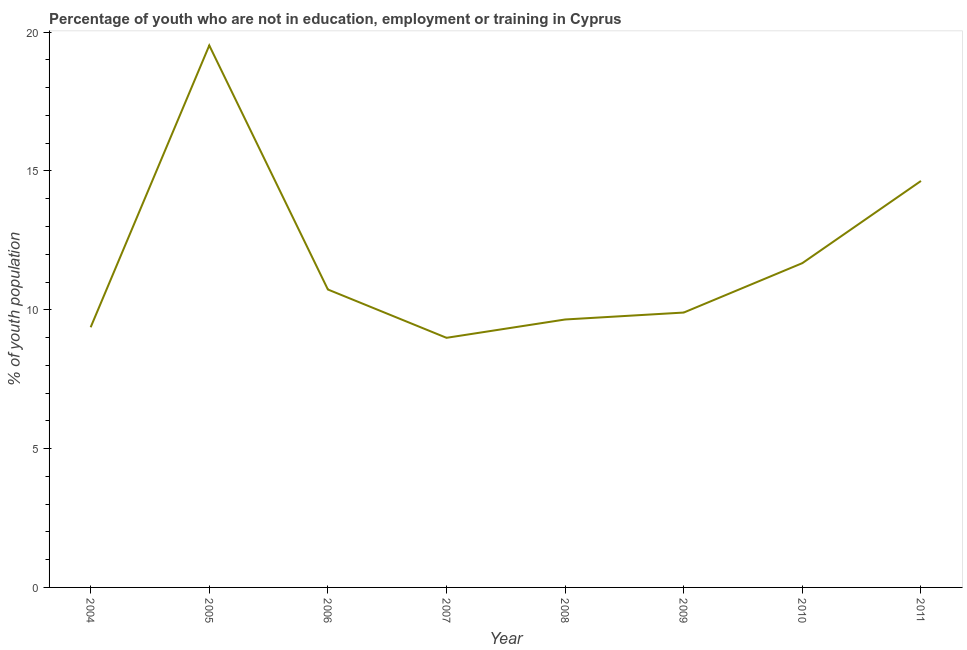What is the unemployed youth population in 2004?
Your response must be concise. 9.37. Across all years, what is the maximum unemployed youth population?
Offer a very short reply. 19.52. Across all years, what is the minimum unemployed youth population?
Ensure brevity in your answer.  8.99. What is the sum of the unemployed youth population?
Provide a short and direct response. 94.48. What is the difference between the unemployed youth population in 2009 and 2011?
Provide a short and direct response. -4.74. What is the average unemployed youth population per year?
Your answer should be very brief. 11.81. What is the median unemployed youth population?
Give a very brief answer. 10.31. Do a majority of the years between 2004 and 2005 (inclusive) have unemployed youth population greater than 13 %?
Offer a terse response. No. What is the ratio of the unemployed youth population in 2006 to that in 2010?
Keep it short and to the point. 0.92. Is the difference between the unemployed youth population in 2006 and 2010 greater than the difference between any two years?
Offer a terse response. No. What is the difference between the highest and the second highest unemployed youth population?
Make the answer very short. 4.88. What is the difference between the highest and the lowest unemployed youth population?
Provide a succinct answer. 10.53. In how many years, is the unemployed youth population greater than the average unemployed youth population taken over all years?
Your response must be concise. 2. Does the unemployed youth population monotonically increase over the years?
Give a very brief answer. No. How many lines are there?
Provide a succinct answer. 1. How many years are there in the graph?
Ensure brevity in your answer.  8. Does the graph contain grids?
Offer a terse response. No. What is the title of the graph?
Your answer should be very brief. Percentage of youth who are not in education, employment or training in Cyprus. What is the label or title of the Y-axis?
Offer a terse response. % of youth population. What is the % of youth population of 2004?
Offer a terse response. 9.37. What is the % of youth population in 2005?
Provide a succinct answer. 19.52. What is the % of youth population in 2006?
Your answer should be compact. 10.73. What is the % of youth population in 2007?
Keep it short and to the point. 8.99. What is the % of youth population of 2008?
Offer a very short reply. 9.65. What is the % of youth population of 2009?
Make the answer very short. 9.9. What is the % of youth population of 2010?
Ensure brevity in your answer.  11.68. What is the % of youth population in 2011?
Ensure brevity in your answer.  14.64. What is the difference between the % of youth population in 2004 and 2005?
Provide a succinct answer. -10.15. What is the difference between the % of youth population in 2004 and 2006?
Give a very brief answer. -1.36. What is the difference between the % of youth population in 2004 and 2007?
Offer a very short reply. 0.38. What is the difference between the % of youth population in 2004 and 2008?
Ensure brevity in your answer.  -0.28. What is the difference between the % of youth population in 2004 and 2009?
Ensure brevity in your answer.  -0.53. What is the difference between the % of youth population in 2004 and 2010?
Give a very brief answer. -2.31. What is the difference between the % of youth population in 2004 and 2011?
Your answer should be compact. -5.27. What is the difference between the % of youth population in 2005 and 2006?
Make the answer very short. 8.79. What is the difference between the % of youth population in 2005 and 2007?
Give a very brief answer. 10.53. What is the difference between the % of youth population in 2005 and 2008?
Your answer should be very brief. 9.87. What is the difference between the % of youth population in 2005 and 2009?
Your answer should be compact. 9.62. What is the difference between the % of youth population in 2005 and 2010?
Your response must be concise. 7.84. What is the difference between the % of youth population in 2005 and 2011?
Your answer should be compact. 4.88. What is the difference between the % of youth population in 2006 and 2007?
Give a very brief answer. 1.74. What is the difference between the % of youth population in 2006 and 2008?
Your answer should be compact. 1.08. What is the difference between the % of youth population in 2006 and 2009?
Make the answer very short. 0.83. What is the difference between the % of youth population in 2006 and 2010?
Your answer should be compact. -0.95. What is the difference between the % of youth population in 2006 and 2011?
Provide a short and direct response. -3.91. What is the difference between the % of youth population in 2007 and 2008?
Keep it short and to the point. -0.66. What is the difference between the % of youth population in 2007 and 2009?
Provide a short and direct response. -0.91. What is the difference between the % of youth population in 2007 and 2010?
Ensure brevity in your answer.  -2.69. What is the difference between the % of youth population in 2007 and 2011?
Offer a very short reply. -5.65. What is the difference between the % of youth population in 2008 and 2009?
Make the answer very short. -0.25. What is the difference between the % of youth population in 2008 and 2010?
Keep it short and to the point. -2.03. What is the difference between the % of youth population in 2008 and 2011?
Offer a very short reply. -4.99. What is the difference between the % of youth population in 2009 and 2010?
Your response must be concise. -1.78. What is the difference between the % of youth population in 2009 and 2011?
Offer a terse response. -4.74. What is the difference between the % of youth population in 2010 and 2011?
Ensure brevity in your answer.  -2.96. What is the ratio of the % of youth population in 2004 to that in 2005?
Keep it short and to the point. 0.48. What is the ratio of the % of youth population in 2004 to that in 2006?
Keep it short and to the point. 0.87. What is the ratio of the % of youth population in 2004 to that in 2007?
Keep it short and to the point. 1.04. What is the ratio of the % of youth population in 2004 to that in 2009?
Keep it short and to the point. 0.95. What is the ratio of the % of youth population in 2004 to that in 2010?
Give a very brief answer. 0.8. What is the ratio of the % of youth population in 2004 to that in 2011?
Your answer should be compact. 0.64. What is the ratio of the % of youth population in 2005 to that in 2006?
Ensure brevity in your answer.  1.82. What is the ratio of the % of youth population in 2005 to that in 2007?
Your response must be concise. 2.17. What is the ratio of the % of youth population in 2005 to that in 2008?
Your answer should be very brief. 2.02. What is the ratio of the % of youth population in 2005 to that in 2009?
Keep it short and to the point. 1.97. What is the ratio of the % of youth population in 2005 to that in 2010?
Make the answer very short. 1.67. What is the ratio of the % of youth population in 2005 to that in 2011?
Provide a short and direct response. 1.33. What is the ratio of the % of youth population in 2006 to that in 2007?
Your answer should be very brief. 1.19. What is the ratio of the % of youth population in 2006 to that in 2008?
Provide a short and direct response. 1.11. What is the ratio of the % of youth population in 2006 to that in 2009?
Give a very brief answer. 1.08. What is the ratio of the % of youth population in 2006 to that in 2010?
Offer a terse response. 0.92. What is the ratio of the % of youth population in 2006 to that in 2011?
Make the answer very short. 0.73. What is the ratio of the % of youth population in 2007 to that in 2008?
Provide a succinct answer. 0.93. What is the ratio of the % of youth population in 2007 to that in 2009?
Offer a very short reply. 0.91. What is the ratio of the % of youth population in 2007 to that in 2010?
Ensure brevity in your answer.  0.77. What is the ratio of the % of youth population in 2007 to that in 2011?
Make the answer very short. 0.61. What is the ratio of the % of youth population in 2008 to that in 2009?
Ensure brevity in your answer.  0.97. What is the ratio of the % of youth population in 2008 to that in 2010?
Offer a terse response. 0.83. What is the ratio of the % of youth population in 2008 to that in 2011?
Ensure brevity in your answer.  0.66. What is the ratio of the % of youth population in 2009 to that in 2010?
Make the answer very short. 0.85. What is the ratio of the % of youth population in 2009 to that in 2011?
Ensure brevity in your answer.  0.68. What is the ratio of the % of youth population in 2010 to that in 2011?
Ensure brevity in your answer.  0.8. 